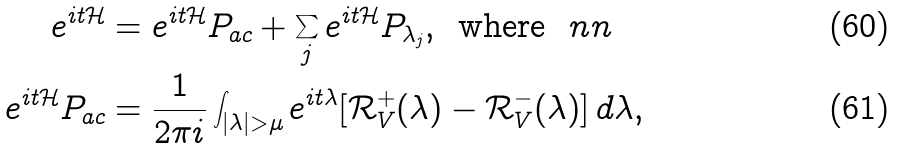Convert formula to latex. <formula><loc_0><loc_0><loc_500><loc_500>e ^ { i t \mathcal { H } } & = e ^ { i t \mathcal { H } } P _ { a c } + \sum _ { j } e ^ { i t \mathcal { H } } P _ { \lambda _ { j } } , \, \text { where } \ n n \\ e ^ { i t \mathcal { H } } P _ { a c } & = \frac { 1 } { 2 \pi i } \int _ { | \lambda | > \mu } e ^ { i t \lambda } [ \mathcal { R } _ { V } ^ { + } ( \lambda ) - \mathcal { R } _ { V } ^ { - } ( \lambda ) ] \, d \lambda ,</formula> 